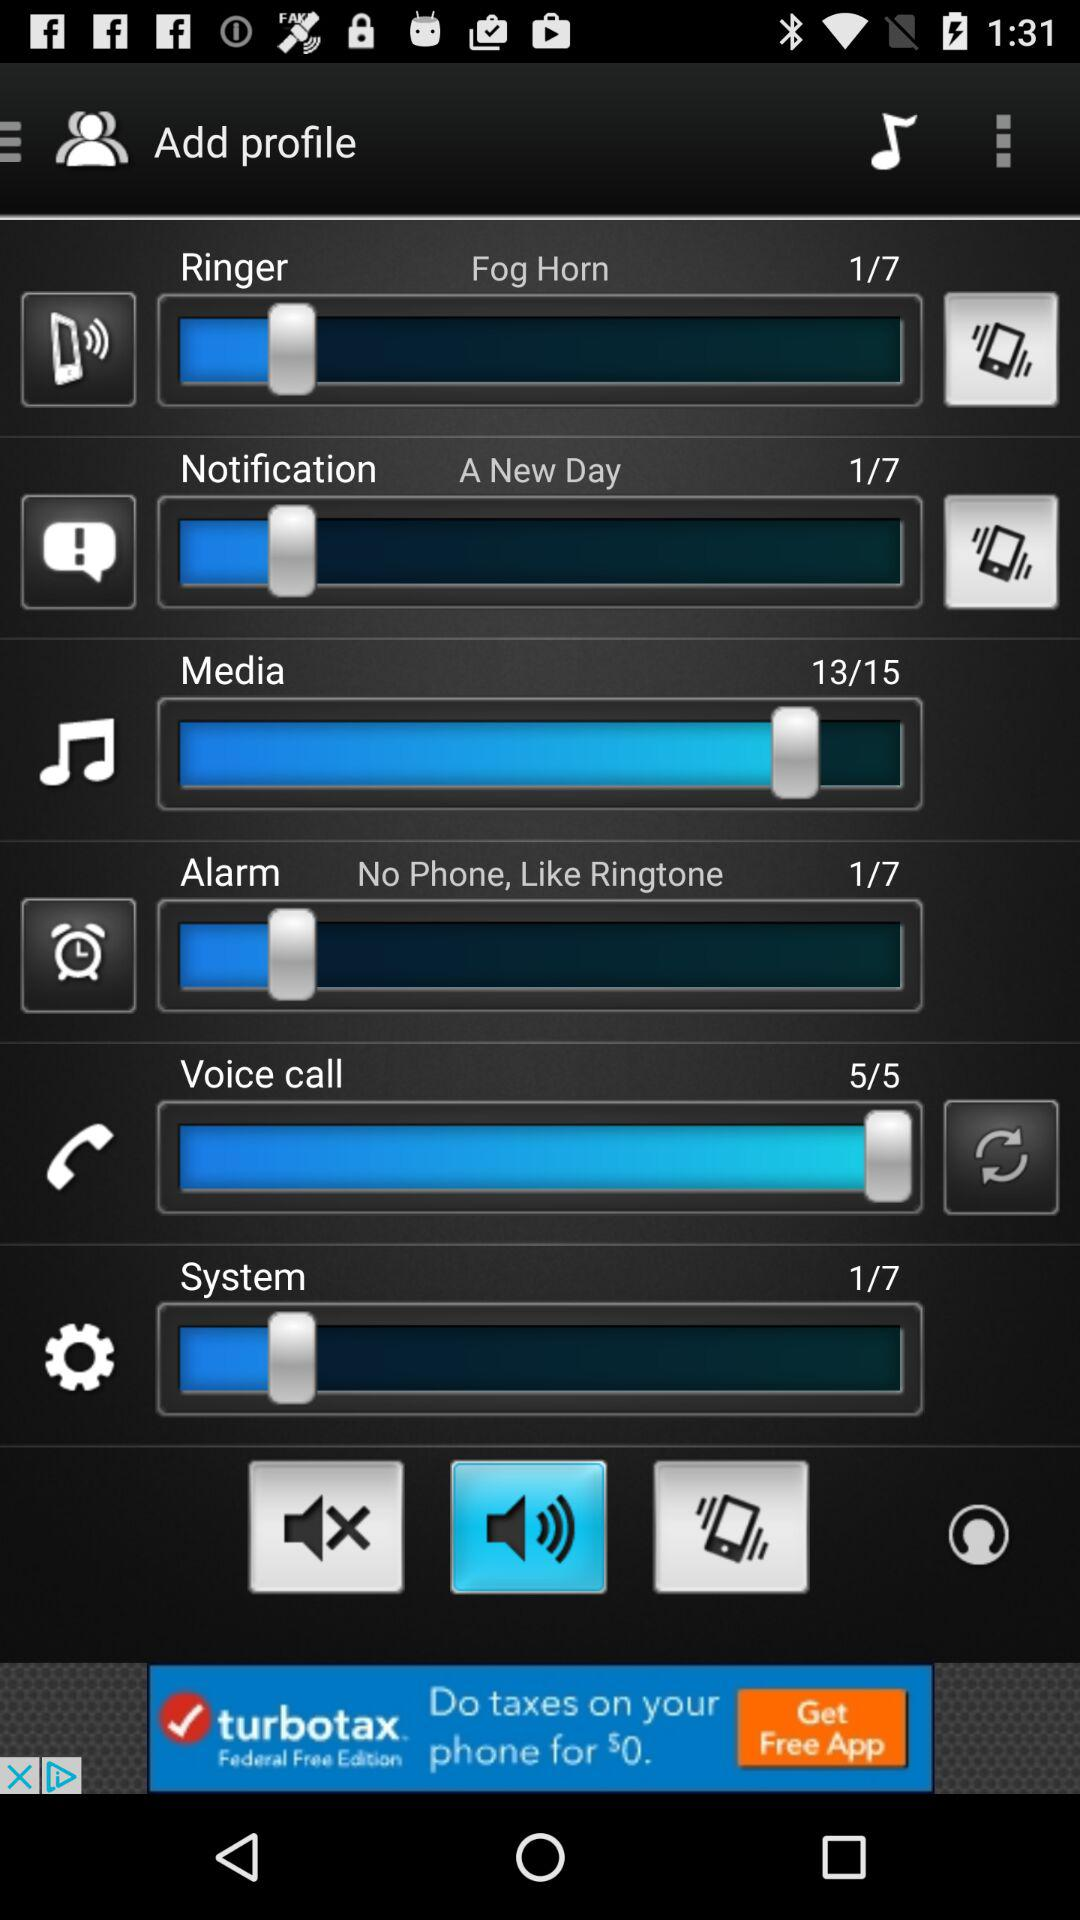What is the notification tone? The notification tone is "A New Day". 